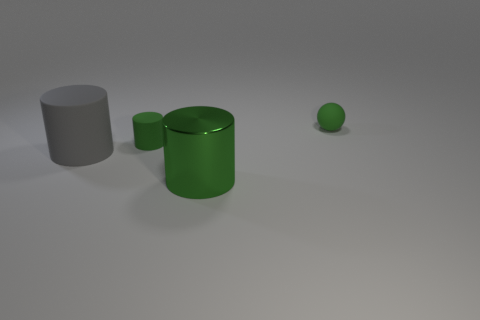What shape is the small object that is the same color as the tiny cylinder?
Make the answer very short. Sphere. Does the tiny rubber ball have the same color as the shiny thing?
Ensure brevity in your answer.  Yes. Is there any other thing that has the same shape as the shiny object?
Keep it short and to the point. Yes. Is the number of gray things less than the number of red shiny cylinders?
Keep it short and to the point. No. What is the object that is to the left of the big green thing and behind the big gray matte cylinder made of?
Provide a succinct answer. Rubber. There is a rubber object to the right of the tiny green cylinder; is there a tiny green matte thing to the right of it?
Make the answer very short. No. What number of things are either large green objects or big blue rubber cylinders?
Make the answer very short. 1. There is a green thing that is both to the left of the tiny matte sphere and behind the big matte cylinder; what shape is it?
Make the answer very short. Cylinder. Are the tiny green object on the left side of the rubber ball and the big green object made of the same material?
Offer a very short reply. No. What number of things are either small rubber spheres or large cylinders behind the shiny object?
Your response must be concise. 2. 